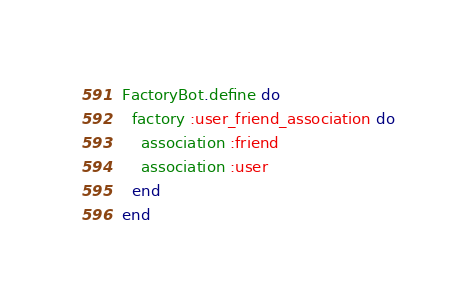Convert code to text. <code><loc_0><loc_0><loc_500><loc_500><_Ruby_>FactoryBot.define do
  factory :user_friend_association do
    association :friend
    association :user
  end
end</code> 